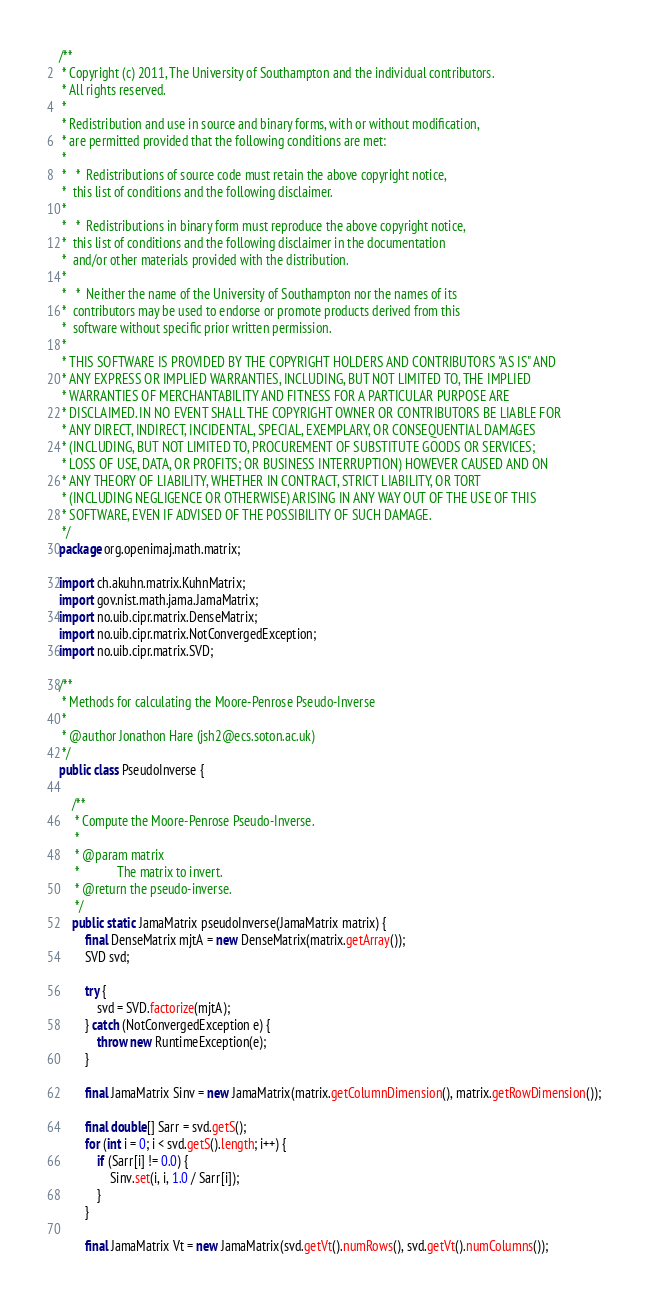Convert code to text. <code><loc_0><loc_0><loc_500><loc_500><_Java_>/**
 * Copyright (c) 2011, The University of Southampton and the individual contributors.
 * All rights reserved.
 *
 * Redistribution and use in source and binary forms, with or without modification,
 * are permitted provided that the following conditions are met:
 *
 *   *  Redistributions of source code must retain the above copyright notice,
 *  this list of conditions and the following disclaimer.
 *
 *   *  Redistributions in binary form must reproduce the above copyright notice,
 *  this list of conditions and the following disclaimer in the documentation
 *  and/or other materials provided with the distribution.
 *
 *   *  Neither the name of the University of Southampton nor the names of its
 *  contributors may be used to endorse or promote products derived from this
 *  software without specific prior written permission.
 *
 * THIS SOFTWARE IS PROVIDED BY THE COPYRIGHT HOLDERS AND CONTRIBUTORS "AS IS" AND
 * ANY EXPRESS OR IMPLIED WARRANTIES, INCLUDING, BUT NOT LIMITED TO, THE IMPLIED
 * WARRANTIES OF MERCHANTABILITY AND FITNESS FOR A PARTICULAR PURPOSE ARE
 * DISCLAIMED. IN NO EVENT SHALL THE COPYRIGHT OWNER OR CONTRIBUTORS BE LIABLE FOR
 * ANY DIRECT, INDIRECT, INCIDENTAL, SPECIAL, EXEMPLARY, OR CONSEQUENTIAL DAMAGES
 * (INCLUDING, BUT NOT LIMITED TO, PROCUREMENT OF SUBSTITUTE GOODS OR SERVICES;
 * LOSS OF USE, DATA, OR PROFITS; OR BUSINESS INTERRUPTION) HOWEVER CAUSED AND ON
 * ANY THEORY OF LIABILITY, WHETHER IN CONTRACT, STRICT LIABILITY, OR TORT
 * (INCLUDING NEGLIGENCE OR OTHERWISE) ARISING IN ANY WAY OUT OF THE USE OF THIS
 * SOFTWARE, EVEN IF ADVISED OF THE POSSIBILITY OF SUCH DAMAGE.
 */
package org.openimaj.math.matrix;

import ch.akuhn.matrix.KuhnMatrix;
import gov.nist.math.jama.JamaMatrix;
import no.uib.cipr.matrix.DenseMatrix;
import no.uib.cipr.matrix.NotConvergedException;
import no.uib.cipr.matrix.SVD;

/**
 * Methods for calculating the Moore-Penrose Pseudo-Inverse
 *
 * @author Jonathon Hare (jsh2@ecs.soton.ac.uk)
 */
public class PseudoInverse {

    /**
     * Compute the Moore-Penrose Pseudo-Inverse.
     *
     * @param matrix
     *            The matrix to invert.
     * @return the pseudo-inverse.
     */
    public static JamaMatrix pseudoInverse(JamaMatrix matrix) {
        final DenseMatrix mjtA = new DenseMatrix(matrix.getArray());
        SVD svd;

        try {
            svd = SVD.factorize(mjtA);
        } catch (NotConvergedException e) {
            throw new RuntimeException(e);
        }

        final JamaMatrix Sinv = new JamaMatrix(matrix.getColumnDimension(), matrix.getRowDimension());

        final double[] Sarr = svd.getS();
        for (int i = 0; i < svd.getS().length; i++) {
            if (Sarr[i] != 0.0) {
                Sinv.set(i, i, 1.0 / Sarr[i]);
            }
        }

        final JamaMatrix Vt = new JamaMatrix(svd.getVt().numRows(), svd.getVt().numColumns());</code> 